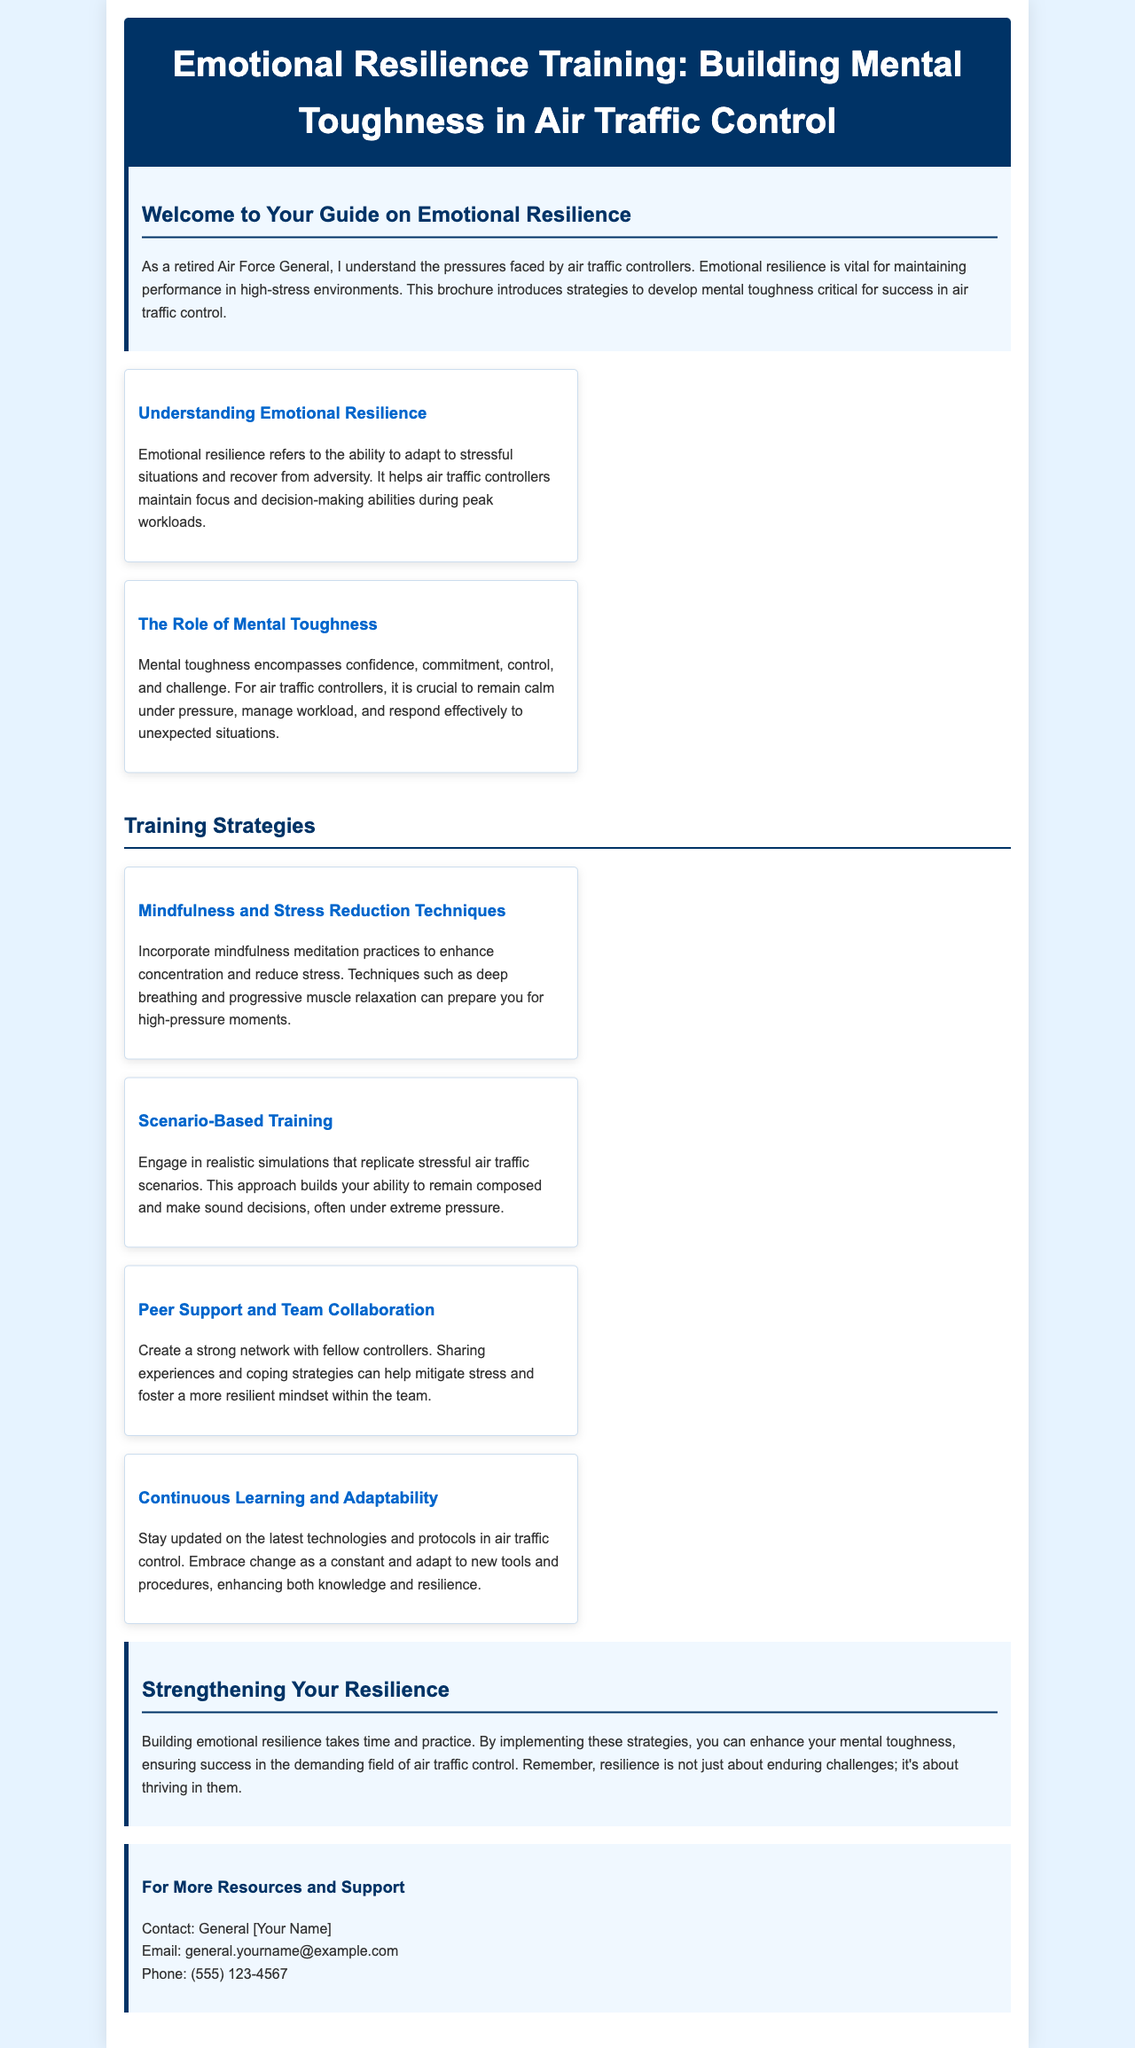what is the title of the brochure? The title is prominently displayed at the top of the document, outlining the focus of the content.
Answer: Emotional Resilience Training: Building Mental Toughness in Air Traffic Control who is the target audience for this training? The introductory section specifies who would benefit from this training based on their role and responsibilities in high-pressure situations.
Answer: air traffic controllers how many training strategies are mentioned in the brochure? The content section lists the various strategies provided, allowing for a simple count of distinct strategies mentioned.
Answer: four what concept helps air traffic controllers recover from adversity? The document explicitly describes this concept in the context of adapting to stress and maintaining focus.
Answer: Emotional resilience which training strategy involves working with fellow controllers? The specific strategy discusses the importance of collaboration among controllers for better support and coping mechanisms.
Answer: Peer Support and Team Collaboration what technique is suggested for stress reduction? The brochure lists a method that can assist in alleviating stress, specifically indicating one popular practice.
Answer: mindfulness meditation what color is used for the header background? The header's background color is mentioned in the styling section, providing a clear visual description.
Answer: dark blue what does the brochure emphasize about resilience? The closing section summarizes a key message regarding the mindset that we should adopt in relation to facing challenges.
Answer: thriving in them 